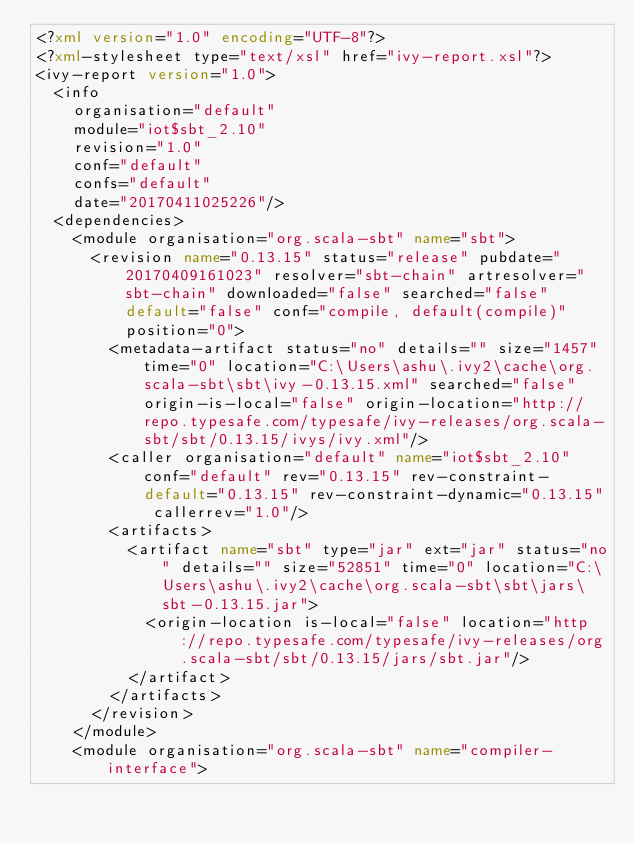<code> <loc_0><loc_0><loc_500><loc_500><_XML_><?xml version="1.0" encoding="UTF-8"?>
<?xml-stylesheet type="text/xsl" href="ivy-report.xsl"?>
<ivy-report version="1.0">
	<info
		organisation="default"
		module="iot$sbt_2.10"
		revision="1.0"
		conf="default"
		confs="default"
		date="20170411025226"/>
	<dependencies>
		<module organisation="org.scala-sbt" name="sbt">
			<revision name="0.13.15" status="release" pubdate="20170409161023" resolver="sbt-chain" artresolver="sbt-chain" downloaded="false" searched="false" default="false" conf="compile, default(compile)" position="0">
				<metadata-artifact status="no" details="" size="1457" time="0" location="C:\Users\ashu\.ivy2\cache\org.scala-sbt\sbt\ivy-0.13.15.xml" searched="false" origin-is-local="false" origin-location="http://repo.typesafe.com/typesafe/ivy-releases/org.scala-sbt/sbt/0.13.15/ivys/ivy.xml"/>
				<caller organisation="default" name="iot$sbt_2.10" conf="default" rev="0.13.15" rev-constraint-default="0.13.15" rev-constraint-dynamic="0.13.15" callerrev="1.0"/>
				<artifacts>
					<artifact name="sbt" type="jar" ext="jar" status="no" details="" size="52851" time="0" location="C:\Users\ashu\.ivy2\cache\org.scala-sbt\sbt\jars\sbt-0.13.15.jar">
						<origin-location is-local="false" location="http://repo.typesafe.com/typesafe/ivy-releases/org.scala-sbt/sbt/0.13.15/jars/sbt.jar"/>
					</artifact>
				</artifacts>
			</revision>
		</module>
		<module organisation="org.scala-sbt" name="compiler-interface"></code> 